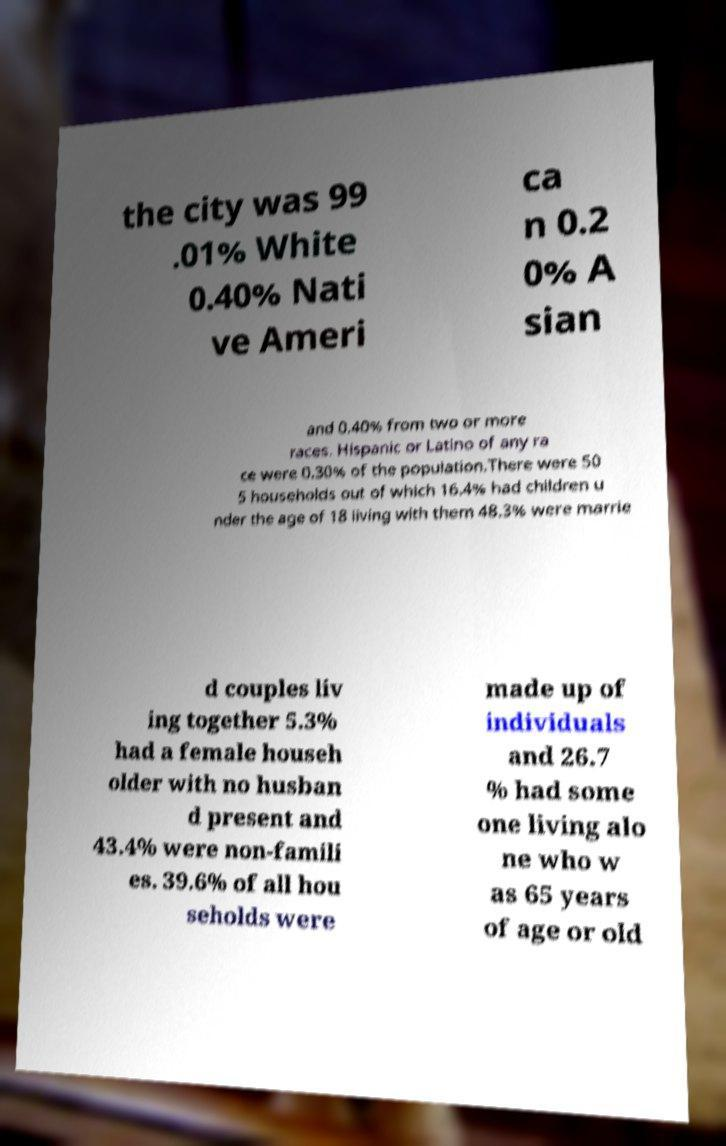Could you extract and type out the text from this image? the city was 99 .01% White 0.40% Nati ve Ameri ca n 0.2 0% A sian and 0.40% from two or more races. Hispanic or Latino of any ra ce were 0.30% of the population.There were 50 5 households out of which 16.4% had children u nder the age of 18 living with them 48.3% were marrie d couples liv ing together 5.3% had a female househ older with no husban d present and 43.4% were non-famili es. 39.6% of all hou seholds were made up of individuals and 26.7 % had some one living alo ne who w as 65 years of age or old 